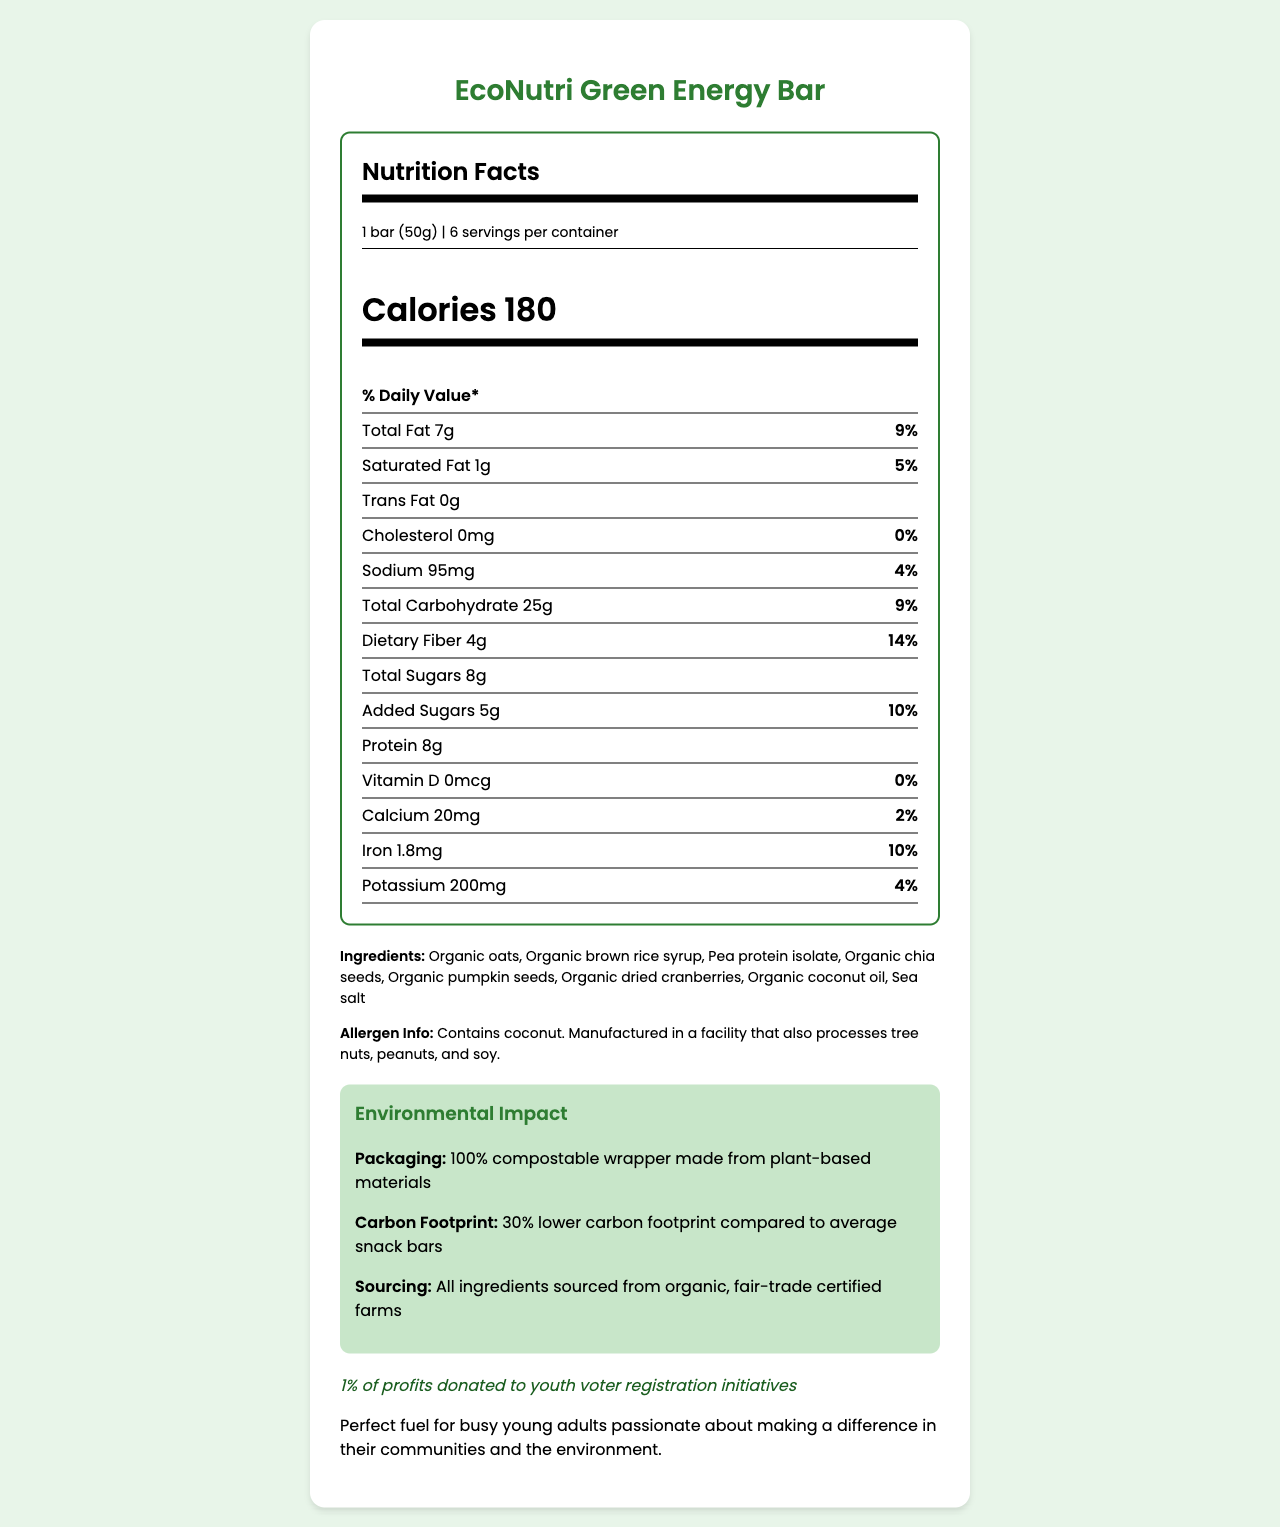what is the serving size of the EcoNutri Green Energy Bar? The serving size is listed at the top of the Nutrition Facts section as "1 bar (50g)."
Answer: 1 bar (50g) how many calories are in one serving of the snack bar? The document specifies "Calories 180" in the Nutrition Facts section.
Answer: 180 what is the percentage of Daily Value for Total Fat? The percentage Daily Value for Total Fat is shown as 9% in the Nutrition Facts section.
Answer: 9% how many total carbohydrates are in a serving? The Nutrition Facts section lists "Total Carbohydrate 25g."
Answer: 25g what is the amount of dietary fiber per serving? The dietary fiber amount is listed as "Dietary Fiber 4g" in the Nutrition Facts section.
Answer: 4g does this product contain any cholesterol? The document states "Cholesterol 0mg," indicating that it contains no cholesterol.
Answer: No how many grams of added sugars does one bar contain? The Nutrition Facts section lists "Added Sugars 5g."
Answer: 5g what is the main source of protein in the EcoNutri Green Energy Bar? A. Organic oats B. Pea protein isolate C. Organic chia seeds D. Organic pumpkin seeds The ingredients list shows "Pea protein isolate" among other ingredients, indicating it is the main source of protein.
Answer: B. Pea protein isolate which ingredient in the bar is a potential allergen? A. Organic oats B. Organic dried cranberries C. Sea salt D. Coconut The allergen information states "Contains coconut."
Answer: D. Coconut is the packaging of the EcoNutri Green Energy Bar environmentally friendly? The document mentions "100% compostable wrapper made from plant-based materials" in the Environmental Impact section.
Answer: Yes does this product contribute to political engagement? The document states that "1% of profits donated to youth voter registration initiatives," showing political engagement.
Answer: Yes does the EcoNutri Green Energy Bar contain Vitamin D? The document lists "Vitamin D 0mcg" with a daily value of "0%."
Answer: No what is the primary target audience for this snack bar? The additional information describes it as "Perfect fuel for busy young adults passionate about making a difference in their communities and the environment."
Answer: Environmentally-conscious young adults summarize the main idea of the document. The document highlights the product's nutritional content, ingredients, allergen information, eco-friendly features, and political engagement efforts, aimed at a young, socially-responsible audience.
Answer: The EcoNutri Green Energy Bar is a healthy, environmentally-friendly snack marketed towards environmentally-conscious young adults. The bar provides energy with a balanced nutrition profile, contains organic ingredients, and utilizes sustainable sourcing. Additionally, the product emphasizes political engagement by donating 1% of profits to youth voter registration initiatives. The packaging is eco-friendly and compostable, further underlining its commitment to the environment. what is the expected market demographic for the EcoNutri Green Energy Bar? The document describes the target audience as environmentally-conscious young adults but does not provide detailed market demographics.
Answer: Cannot be determined 